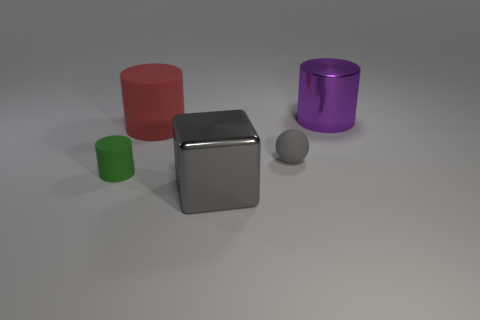Add 1 big brown shiny balls. How many objects exist? 6 Subtract all large red matte cylinders. How many cylinders are left? 2 Subtract all balls. How many objects are left? 4 Subtract 1 blocks. How many blocks are left? 0 Subtract 0 yellow cylinders. How many objects are left? 5 Subtract all green balls. Subtract all gray cylinders. How many balls are left? 1 Subtract all brown balls. How many red cylinders are left? 1 Subtract all purple cylinders. Subtract all big rubber things. How many objects are left? 3 Add 4 gray matte things. How many gray matte things are left? 5 Add 5 tiny blue balls. How many tiny blue balls exist? 5 